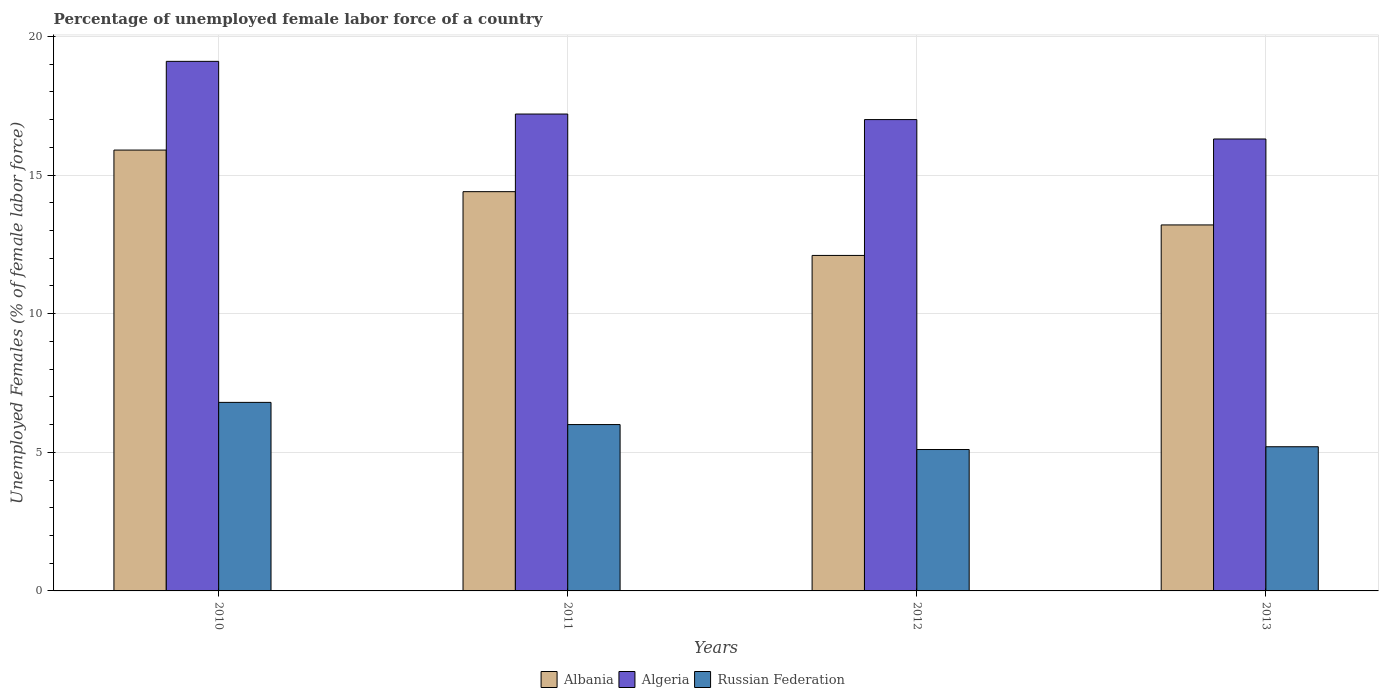Are the number of bars on each tick of the X-axis equal?
Your response must be concise. Yes. Across all years, what is the maximum percentage of unemployed female labor force in Albania?
Provide a succinct answer. 15.9. Across all years, what is the minimum percentage of unemployed female labor force in Russian Federation?
Provide a short and direct response. 5.1. In which year was the percentage of unemployed female labor force in Albania maximum?
Your answer should be compact. 2010. What is the total percentage of unemployed female labor force in Albania in the graph?
Provide a short and direct response. 55.6. What is the difference between the percentage of unemployed female labor force in Algeria in 2011 and that in 2013?
Your response must be concise. 0.9. What is the difference between the percentage of unemployed female labor force in Russian Federation in 2010 and the percentage of unemployed female labor force in Albania in 2012?
Ensure brevity in your answer.  -5.3. What is the average percentage of unemployed female labor force in Algeria per year?
Your answer should be very brief. 17.4. In the year 2012, what is the difference between the percentage of unemployed female labor force in Albania and percentage of unemployed female labor force in Algeria?
Offer a terse response. -4.9. What is the ratio of the percentage of unemployed female labor force in Albania in 2012 to that in 2013?
Offer a very short reply. 0.92. What is the difference between the highest and the second highest percentage of unemployed female labor force in Algeria?
Your answer should be compact. 1.9. What is the difference between the highest and the lowest percentage of unemployed female labor force in Albania?
Your answer should be very brief. 3.8. Is the sum of the percentage of unemployed female labor force in Russian Federation in 2010 and 2011 greater than the maximum percentage of unemployed female labor force in Algeria across all years?
Your answer should be very brief. No. What does the 1st bar from the left in 2011 represents?
Make the answer very short. Albania. What does the 3rd bar from the right in 2010 represents?
Your answer should be very brief. Albania. Are all the bars in the graph horizontal?
Your answer should be very brief. No. What is the difference between two consecutive major ticks on the Y-axis?
Offer a very short reply. 5. Does the graph contain any zero values?
Your answer should be compact. No. Does the graph contain grids?
Offer a terse response. Yes. Where does the legend appear in the graph?
Your answer should be very brief. Bottom center. How many legend labels are there?
Provide a short and direct response. 3. What is the title of the graph?
Your answer should be compact. Percentage of unemployed female labor force of a country. What is the label or title of the Y-axis?
Your response must be concise. Unemployed Females (% of female labor force). What is the Unemployed Females (% of female labor force) in Albania in 2010?
Your answer should be very brief. 15.9. What is the Unemployed Females (% of female labor force) in Algeria in 2010?
Your answer should be compact. 19.1. What is the Unemployed Females (% of female labor force) of Russian Federation in 2010?
Provide a short and direct response. 6.8. What is the Unemployed Females (% of female labor force) of Albania in 2011?
Your answer should be very brief. 14.4. What is the Unemployed Females (% of female labor force) in Algeria in 2011?
Your answer should be very brief. 17.2. What is the Unemployed Females (% of female labor force) in Russian Federation in 2011?
Your answer should be compact. 6. What is the Unemployed Females (% of female labor force) of Albania in 2012?
Keep it short and to the point. 12.1. What is the Unemployed Females (% of female labor force) of Algeria in 2012?
Give a very brief answer. 17. What is the Unemployed Females (% of female labor force) of Russian Federation in 2012?
Your response must be concise. 5.1. What is the Unemployed Females (% of female labor force) of Albania in 2013?
Provide a short and direct response. 13.2. What is the Unemployed Females (% of female labor force) in Algeria in 2013?
Offer a terse response. 16.3. What is the Unemployed Females (% of female labor force) in Russian Federation in 2013?
Your response must be concise. 5.2. Across all years, what is the maximum Unemployed Females (% of female labor force) of Albania?
Keep it short and to the point. 15.9. Across all years, what is the maximum Unemployed Females (% of female labor force) of Algeria?
Make the answer very short. 19.1. Across all years, what is the maximum Unemployed Females (% of female labor force) of Russian Federation?
Ensure brevity in your answer.  6.8. Across all years, what is the minimum Unemployed Females (% of female labor force) of Albania?
Your answer should be very brief. 12.1. Across all years, what is the minimum Unemployed Females (% of female labor force) of Algeria?
Offer a very short reply. 16.3. Across all years, what is the minimum Unemployed Females (% of female labor force) in Russian Federation?
Offer a terse response. 5.1. What is the total Unemployed Females (% of female labor force) of Albania in the graph?
Your response must be concise. 55.6. What is the total Unemployed Females (% of female labor force) in Algeria in the graph?
Keep it short and to the point. 69.6. What is the total Unemployed Females (% of female labor force) in Russian Federation in the graph?
Offer a terse response. 23.1. What is the difference between the Unemployed Females (% of female labor force) in Albania in 2010 and that in 2011?
Make the answer very short. 1.5. What is the difference between the Unemployed Females (% of female labor force) in Russian Federation in 2010 and that in 2012?
Provide a short and direct response. 1.7. What is the difference between the Unemployed Females (% of female labor force) of Albania in 2010 and that in 2013?
Offer a very short reply. 2.7. What is the difference between the Unemployed Females (% of female labor force) in Algeria in 2010 and that in 2013?
Give a very brief answer. 2.8. What is the difference between the Unemployed Females (% of female labor force) in Algeria in 2011 and that in 2012?
Give a very brief answer. 0.2. What is the difference between the Unemployed Females (% of female labor force) in Algeria in 2011 and that in 2013?
Offer a terse response. 0.9. What is the difference between the Unemployed Females (% of female labor force) in Albania in 2012 and that in 2013?
Your answer should be very brief. -1.1. What is the difference between the Unemployed Females (% of female labor force) in Russian Federation in 2012 and that in 2013?
Your answer should be very brief. -0.1. What is the difference between the Unemployed Females (% of female labor force) of Albania in 2010 and the Unemployed Females (% of female labor force) of Algeria in 2011?
Provide a succinct answer. -1.3. What is the difference between the Unemployed Females (% of female labor force) of Algeria in 2010 and the Unemployed Females (% of female labor force) of Russian Federation in 2012?
Provide a short and direct response. 14. What is the difference between the Unemployed Females (% of female labor force) in Albania in 2010 and the Unemployed Females (% of female labor force) in Russian Federation in 2013?
Ensure brevity in your answer.  10.7. What is the difference between the Unemployed Females (% of female labor force) of Algeria in 2010 and the Unemployed Females (% of female labor force) of Russian Federation in 2013?
Provide a succinct answer. 13.9. What is the difference between the Unemployed Females (% of female labor force) of Albania in 2011 and the Unemployed Females (% of female labor force) of Algeria in 2012?
Offer a very short reply. -2.6. What is the difference between the Unemployed Females (% of female labor force) of Algeria in 2011 and the Unemployed Females (% of female labor force) of Russian Federation in 2012?
Your response must be concise. 12.1. What is the difference between the Unemployed Females (% of female labor force) in Albania in 2011 and the Unemployed Females (% of female labor force) in Russian Federation in 2013?
Provide a succinct answer. 9.2. What is the difference between the Unemployed Females (% of female labor force) in Algeria in 2011 and the Unemployed Females (% of female labor force) in Russian Federation in 2013?
Your response must be concise. 12. What is the difference between the Unemployed Females (% of female labor force) in Albania in 2012 and the Unemployed Females (% of female labor force) in Algeria in 2013?
Make the answer very short. -4.2. What is the difference between the Unemployed Females (% of female labor force) of Algeria in 2012 and the Unemployed Females (% of female labor force) of Russian Federation in 2013?
Make the answer very short. 11.8. What is the average Unemployed Females (% of female labor force) in Albania per year?
Offer a terse response. 13.9. What is the average Unemployed Females (% of female labor force) of Russian Federation per year?
Give a very brief answer. 5.78. In the year 2010, what is the difference between the Unemployed Females (% of female labor force) in Albania and Unemployed Females (% of female labor force) in Russian Federation?
Offer a terse response. 9.1. In the year 2010, what is the difference between the Unemployed Females (% of female labor force) in Algeria and Unemployed Females (% of female labor force) in Russian Federation?
Ensure brevity in your answer.  12.3. In the year 2011, what is the difference between the Unemployed Females (% of female labor force) of Albania and Unemployed Females (% of female labor force) of Russian Federation?
Ensure brevity in your answer.  8.4. In the year 2011, what is the difference between the Unemployed Females (% of female labor force) of Algeria and Unemployed Females (% of female labor force) of Russian Federation?
Your answer should be compact. 11.2. In the year 2012, what is the difference between the Unemployed Females (% of female labor force) in Albania and Unemployed Females (% of female labor force) in Algeria?
Offer a very short reply. -4.9. In the year 2012, what is the difference between the Unemployed Females (% of female labor force) of Algeria and Unemployed Females (% of female labor force) of Russian Federation?
Ensure brevity in your answer.  11.9. In the year 2013, what is the difference between the Unemployed Females (% of female labor force) of Albania and Unemployed Females (% of female labor force) of Algeria?
Offer a terse response. -3.1. In the year 2013, what is the difference between the Unemployed Females (% of female labor force) of Albania and Unemployed Females (% of female labor force) of Russian Federation?
Ensure brevity in your answer.  8. In the year 2013, what is the difference between the Unemployed Females (% of female labor force) in Algeria and Unemployed Females (% of female labor force) in Russian Federation?
Provide a succinct answer. 11.1. What is the ratio of the Unemployed Females (% of female labor force) of Albania in 2010 to that in 2011?
Provide a succinct answer. 1.1. What is the ratio of the Unemployed Females (% of female labor force) in Algeria in 2010 to that in 2011?
Offer a very short reply. 1.11. What is the ratio of the Unemployed Females (% of female labor force) in Russian Federation in 2010 to that in 2011?
Offer a very short reply. 1.13. What is the ratio of the Unemployed Females (% of female labor force) of Albania in 2010 to that in 2012?
Your answer should be compact. 1.31. What is the ratio of the Unemployed Females (% of female labor force) of Algeria in 2010 to that in 2012?
Your answer should be very brief. 1.12. What is the ratio of the Unemployed Females (% of female labor force) in Russian Federation in 2010 to that in 2012?
Your answer should be compact. 1.33. What is the ratio of the Unemployed Females (% of female labor force) in Albania in 2010 to that in 2013?
Keep it short and to the point. 1.2. What is the ratio of the Unemployed Females (% of female labor force) in Algeria in 2010 to that in 2013?
Offer a very short reply. 1.17. What is the ratio of the Unemployed Females (% of female labor force) in Russian Federation in 2010 to that in 2013?
Make the answer very short. 1.31. What is the ratio of the Unemployed Females (% of female labor force) in Albania in 2011 to that in 2012?
Make the answer very short. 1.19. What is the ratio of the Unemployed Females (% of female labor force) of Algeria in 2011 to that in 2012?
Offer a very short reply. 1.01. What is the ratio of the Unemployed Females (% of female labor force) of Russian Federation in 2011 to that in 2012?
Your response must be concise. 1.18. What is the ratio of the Unemployed Females (% of female labor force) of Albania in 2011 to that in 2013?
Provide a short and direct response. 1.09. What is the ratio of the Unemployed Females (% of female labor force) in Algeria in 2011 to that in 2013?
Offer a very short reply. 1.06. What is the ratio of the Unemployed Females (% of female labor force) of Russian Federation in 2011 to that in 2013?
Make the answer very short. 1.15. What is the ratio of the Unemployed Females (% of female labor force) of Albania in 2012 to that in 2013?
Provide a succinct answer. 0.92. What is the ratio of the Unemployed Females (% of female labor force) of Algeria in 2012 to that in 2013?
Your answer should be compact. 1.04. What is the ratio of the Unemployed Females (% of female labor force) in Russian Federation in 2012 to that in 2013?
Your answer should be very brief. 0.98. What is the difference between the highest and the second highest Unemployed Females (% of female labor force) in Algeria?
Provide a succinct answer. 1.9. What is the difference between the highest and the lowest Unemployed Females (% of female labor force) of Albania?
Provide a succinct answer. 3.8. What is the difference between the highest and the lowest Unemployed Females (% of female labor force) in Algeria?
Offer a very short reply. 2.8. What is the difference between the highest and the lowest Unemployed Females (% of female labor force) of Russian Federation?
Your answer should be very brief. 1.7. 